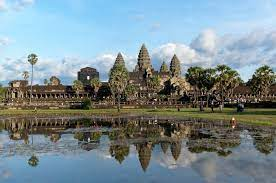Describe the ambiance and atmosphere of the place. The ambiance of Angkor Wat is serene and majestic, enveloped in an aura of historical significance and natural beauty. The gentle ripple of the water reflecting the ancient stone structures creates a peaceful atmosphere. The clear blue sky with scattered white clouds adds a calming backdrop. The lush greenery surrounding the temple complex enhances the sense of tranquility. Visitors are likely to feel a profound sense of awe and reverence as they explore the intricate architecture amidst such a picturesque setting. What historical significance does this place have? Angkor Wat is one of the most significant archaeological sites in Southeast Asia and a symbol of Cambodia. Built in the early 12th century by King Suryavarman II, it was originally dedicated to the Hindu god Vishnu and later became a Buddhist temple. The complex is renowned for its classical Khmer architecture and is considered the largest religious monument in the world. It has been a focal point of cultural, religious, and political significance throughout Cambodian history. The intricate bas-reliefs and carvings depict various historical and mythological scenes, offering a glimpse into the ancient civilization that constructed it. Imagine there are mythical creatures inhabiting this complex, what kind would they be and what might they be doing? In a mystical version of Angkor Wat, the complex would be inhabited by celestial Apsaras—ethereal dancers who perform under the moonlight, their graceful movements bringing the stone carvings to life. Serpentine Naga would guard the temple’s perimeters, their eyes glowing softly as they protect the sacred grounds from malevolent spirits. Majestic Garudas could be seen soaring above, their wings casting shimmering shadows over the reflective waters. Beneath the reflection in the tranquil pool, mythical creatures like Makara—half terrestrial beast and half aquatic—playfully swim, adding an extra layer of enchantment to the serene setting. Every dusk, the entire temple complex would resonate with a harmonious symphony as these mythical beings interact in a world where history and mythology intertwine seamlessly. Create a short story set in this place, focussed on a single significant event. In the heart of Angkor Wat, nestled under the main spire, a hidden chamber was discovered by a monk named Sarath. For centuries, legends spoke of a mystical artifact known as the 'Lotus of Eternity,' said to grant wisdom and peace to anyone who gazes upon its petals. Guided by ethereal whispers in his dreams, Sarath uncovered the chamber during a meditative trance. As he entered, the air seemed to shimmer with unseen energy. There, at the chamber’s center, floated the Lotus of Eternity, surrounded by a soft, radiant glow. The monk, with reverence, approached the artifact and felt an overwhelming sense of tranquility wash over him. His vision broadened as he glimpsed the entirety of human history, understanding its interconnectedness and finding profound peace. The artifact, however, vanished after revealing its wisdom, leaving behind an eternal blessing on Angkor Wat. Its presence is subtly felt by every visitor, in the tranquility of the reflection pool and the reverence in the temple’s stone carvings, making the site a global beacon of peace and wisdom. 